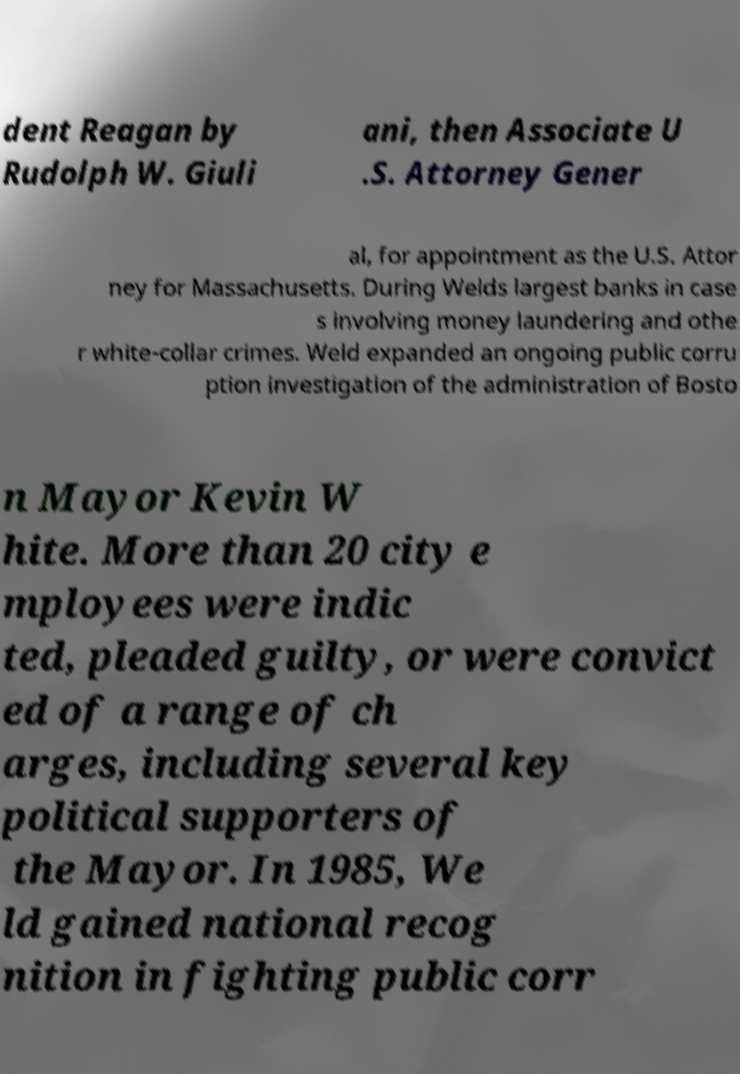What messages or text are displayed in this image? I need them in a readable, typed format. dent Reagan by Rudolph W. Giuli ani, then Associate U .S. Attorney Gener al, for appointment as the U.S. Attor ney for Massachusetts. During Welds largest banks in case s involving money laundering and othe r white-collar crimes. Weld expanded an ongoing public corru ption investigation of the administration of Bosto n Mayor Kevin W hite. More than 20 city e mployees were indic ted, pleaded guilty, or were convict ed of a range of ch arges, including several key political supporters of the Mayor. In 1985, We ld gained national recog nition in fighting public corr 